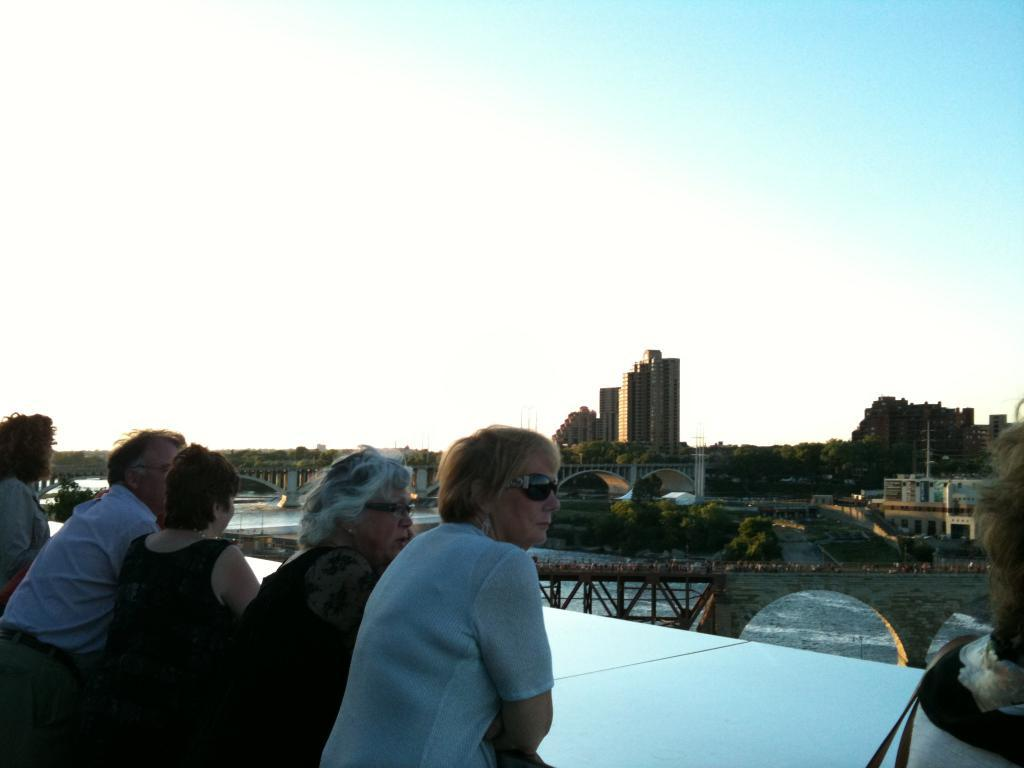What can be seen in the image involving people? There are persons standing in the image. What structures are present in the image that connect areas? There are bridges in the image. What natural element is visible in the image? There is water visible in the image. What type of man-made structures can be seen in the image? There are buildings in the image. What type of vegetation is present in the image? There are trees in the image. What is visible in the background of the image? The sky is visible in the background of the image. What type of throat condition can be seen in the image? There is no mention of any throat condition in the image. What type of chin is visible on the persons in the image? There is no specific chin type mentioned or visible in the image. 